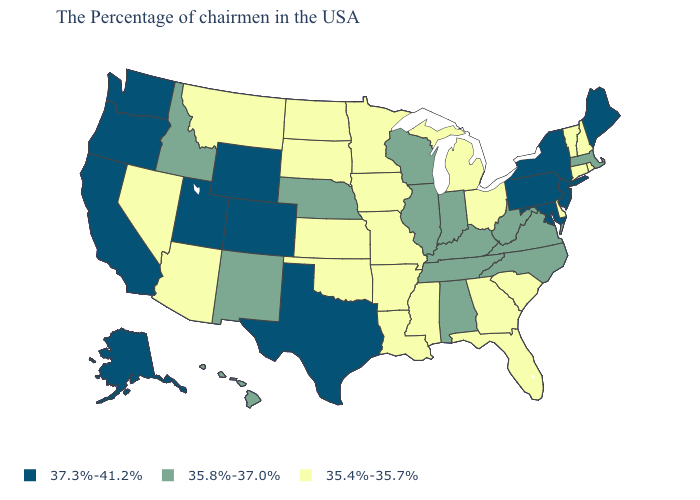What is the value of Tennessee?
Give a very brief answer. 35.8%-37.0%. Name the states that have a value in the range 37.3%-41.2%?
Give a very brief answer. Maine, New York, New Jersey, Maryland, Pennsylvania, Texas, Wyoming, Colorado, Utah, California, Washington, Oregon, Alaska. Is the legend a continuous bar?
Concise answer only. No. Among the states that border Delaware , which have the highest value?
Concise answer only. New Jersey, Maryland, Pennsylvania. What is the value of New York?
Short answer required. 37.3%-41.2%. Among the states that border Washington , does Idaho have the lowest value?
Keep it brief. Yes. Among the states that border Iowa , does Illinois have the highest value?
Short answer required. Yes. Which states have the lowest value in the South?
Write a very short answer. Delaware, South Carolina, Florida, Georgia, Mississippi, Louisiana, Arkansas, Oklahoma. What is the value of Alabama?
Quick response, please. 35.8%-37.0%. What is the value of Utah?
Write a very short answer. 37.3%-41.2%. Name the states that have a value in the range 35.8%-37.0%?
Short answer required. Massachusetts, Virginia, North Carolina, West Virginia, Kentucky, Indiana, Alabama, Tennessee, Wisconsin, Illinois, Nebraska, New Mexico, Idaho, Hawaii. What is the lowest value in states that border Maine?
Give a very brief answer. 35.4%-35.7%. Does Michigan have the lowest value in the MidWest?
Short answer required. Yes. Name the states that have a value in the range 37.3%-41.2%?
Be succinct. Maine, New York, New Jersey, Maryland, Pennsylvania, Texas, Wyoming, Colorado, Utah, California, Washington, Oregon, Alaska. Name the states that have a value in the range 37.3%-41.2%?
Concise answer only. Maine, New York, New Jersey, Maryland, Pennsylvania, Texas, Wyoming, Colorado, Utah, California, Washington, Oregon, Alaska. 